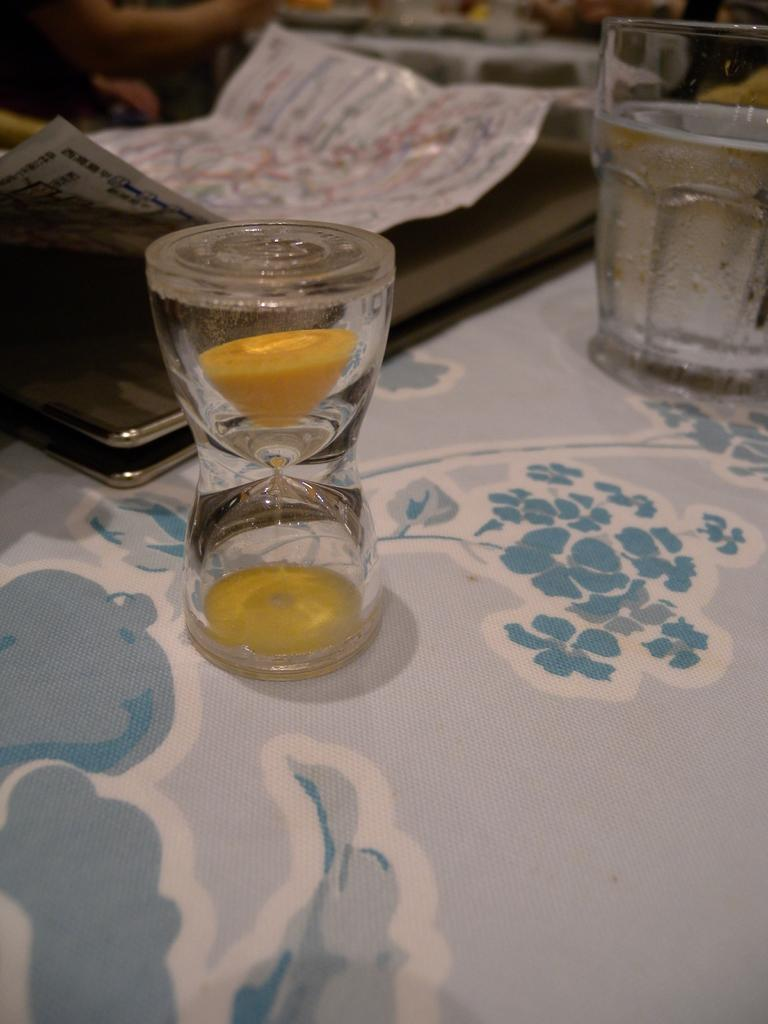What is the main object in the image? There is a sand timer in the image. Can you describe the object behind the sand timer? There is another object behind the sand timer, but its specific details are not mentioned in the facts. What can be seen on the right side of the image? There is a glass with a drink on the right side of the image. What type of plant is growing in the glass with a drink? There is no plant growing in the glass with a drink; it contains a drink. Can you tell me the title of the book on the snail is reading in the image? There is no snail or book present in the image. 